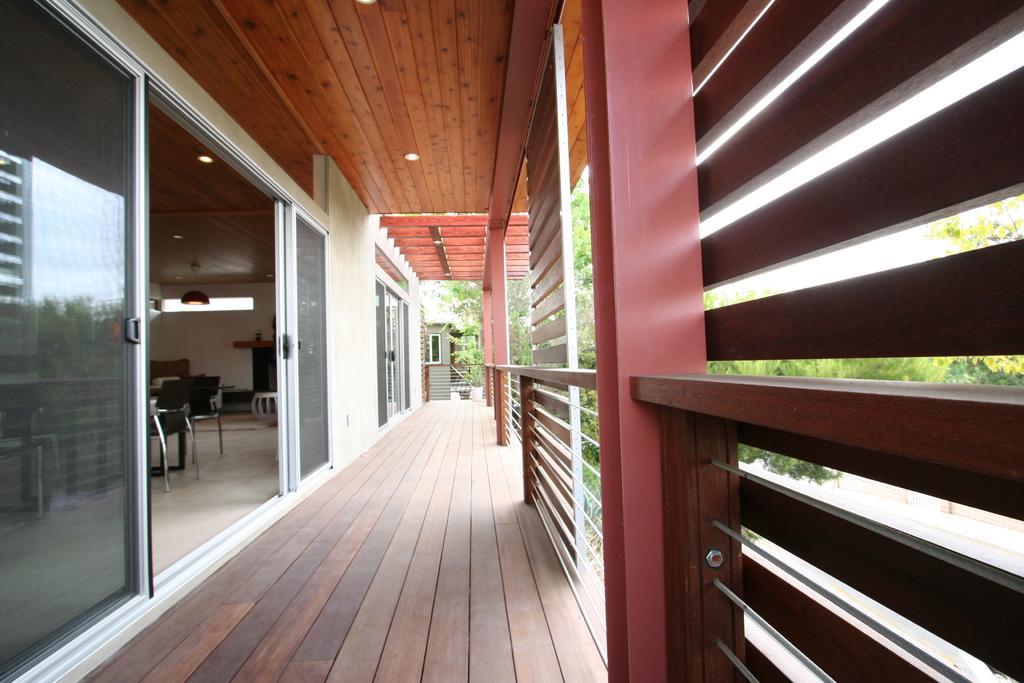Describe this image in one or two sentences. In the foreground of this image, there is a floor, wooden grill on the right and few glass doors on the left. Behind the glass doors, there are few objects and chairs on the floor and lights to the ceiling. In the background, there are trees. 